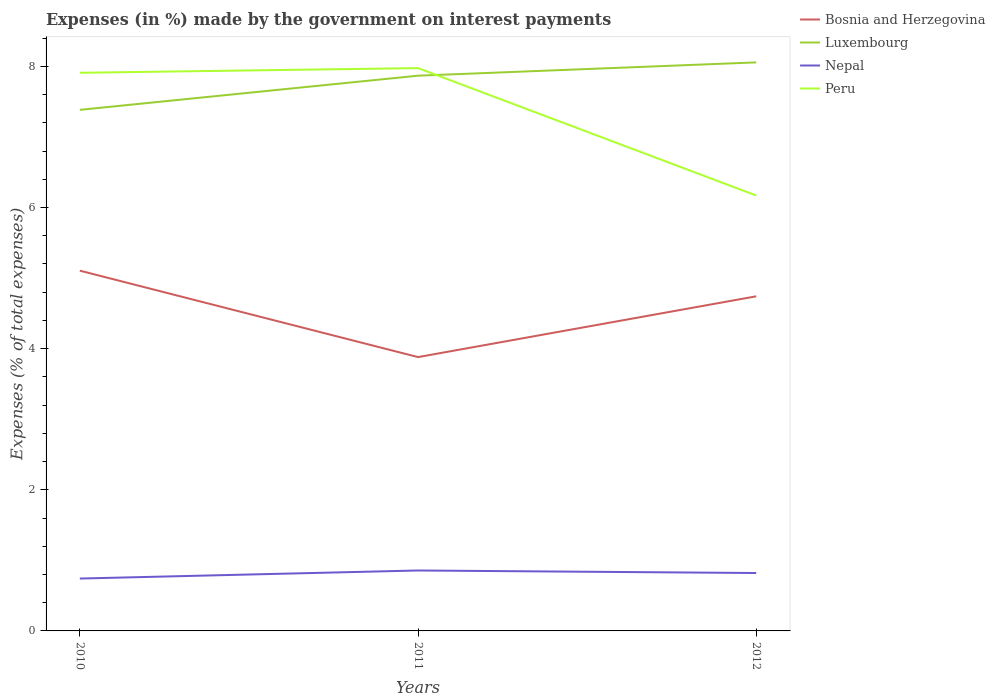How many different coloured lines are there?
Make the answer very short. 4. Across all years, what is the maximum percentage of expenses made by the government on interest payments in Luxembourg?
Your answer should be very brief. 7.38. In which year was the percentage of expenses made by the government on interest payments in Bosnia and Herzegovina maximum?
Provide a short and direct response. 2011. What is the total percentage of expenses made by the government on interest payments in Luxembourg in the graph?
Your answer should be compact. -0.67. What is the difference between the highest and the second highest percentage of expenses made by the government on interest payments in Nepal?
Give a very brief answer. 0.11. What is the difference between the highest and the lowest percentage of expenses made by the government on interest payments in Peru?
Provide a succinct answer. 2. Is the percentage of expenses made by the government on interest payments in Bosnia and Herzegovina strictly greater than the percentage of expenses made by the government on interest payments in Luxembourg over the years?
Make the answer very short. Yes. How many lines are there?
Provide a succinct answer. 4. Are the values on the major ticks of Y-axis written in scientific E-notation?
Offer a very short reply. No. Does the graph contain any zero values?
Make the answer very short. No. Does the graph contain grids?
Offer a terse response. No. How many legend labels are there?
Make the answer very short. 4. How are the legend labels stacked?
Your answer should be compact. Vertical. What is the title of the graph?
Your answer should be very brief. Expenses (in %) made by the government on interest payments. What is the label or title of the Y-axis?
Ensure brevity in your answer.  Expenses (% of total expenses). What is the Expenses (% of total expenses) of Bosnia and Herzegovina in 2010?
Your answer should be very brief. 5.11. What is the Expenses (% of total expenses) of Luxembourg in 2010?
Provide a succinct answer. 7.38. What is the Expenses (% of total expenses) of Nepal in 2010?
Give a very brief answer. 0.74. What is the Expenses (% of total expenses) of Peru in 2010?
Your answer should be very brief. 7.91. What is the Expenses (% of total expenses) in Bosnia and Herzegovina in 2011?
Your answer should be compact. 3.88. What is the Expenses (% of total expenses) in Luxembourg in 2011?
Ensure brevity in your answer.  7.87. What is the Expenses (% of total expenses) in Nepal in 2011?
Make the answer very short. 0.86. What is the Expenses (% of total expenses) of Peru in 2011?
Offer a terse response. 7.98. What is the Expenses (% of total expenses) in Bosnia and Herzegovina in 2012?
Offer a terse response. 4.74. What is the Expenses (% of total expenses) of Luxembourg in 2012?
Your answer should be very brief. 8.06. What is the Expenses (% of total expenses) in Nepal in 2012?
Give a very brief answer. 0.82. What is the Expenses (% of total expenses) in Peru in 2012?
Make the answer very short. 6.17. Across all years, what is the maximum Expenses (% of total expenses) in Bosnia and Herzegovina?
Give a very brief answer. 5.11. Across all years, what is the maximum Expenses (% of total expenses) of Luxembourg?
Offer a very short reply. 8.06. Across all years, what is the maximum Expenses (% of total expenses) in Nepal?
Provide a succinct answer. 0.86. Across all years, what is the maximum Expenses (% of total expenses) in Peru?
Provide a succinct answer. 7.98. Across all years, what is the minimum Expenses (% of total expenses) in Bosnia and Herzegovina?
Provide a succinct answer. 3.88. Across all years, what is the minimum Expenses (% of total expenses) in Luxembourg?
Your answer should be very brief. 7.38. Across all years, what is the minimum Expenses (% of total expenses) in Nepal?
Ensure brevity in your answer.  0.74. Across all years, what is the minimum Expenses (% of total expenses) of Peru?
Keep it short and to the point. 6.17. What is the total Expenses (% of total expenses) of Bosnia and Herzegovina in the graph?
Provide a short and direct response. 13.73. What is the total Expenses (% of total expenses) of Luxembourg in the graph?
Your response must be concise. 23.31. What is the total Expenses (% of total expenses) in Nepal in the graph?
Offer a very short reply. 2.42. What is the total Expenses (% of total expenses) of Peru in the graph?
Give a very brief answer. 22.05. What is the difference between the Expenses (% of total expenses) in Bosnia and Herzegovina in 2010 and that in 2011?
Your response must be concise. 1.22. What is the difference between the Expenses (% of total expenses) of Luxembourg in 2010 and that in 2011?
Make the answer very short. -0.48. What is the difference between the Expenses (% of total expenses) of Nepal in 2010 and that in 2011?
Provide a succinct answer. -0.11. What is the difference between the Expenses (% of total expenses) of Peru in 2010 and that in 2011?
Offer a terse response. -0.07. What is the difference between the Expenses (% of total expenses) in Bosnia and Herzegovina in 2010 and that in 2012?
Ensure brevity in your answer.  0.36. What is the difference between the Expenses (% of total expenses) of Luxembourg in 2010 and that in 2012?
Make the answer very short. -0.67. What is the difference between the Expenses (% of total expenses) of Nepal in 2010 and that in 2012?
Your response must be concise. -0.08. What is the difference between the Expenses (% of total expenses) of Peru in 2010 and that in 2012?
Provide a short and direct response. 1.74. What is the difference between the Expenses (% of total expenses) of Bosnia and Herzegovina in 2011 and that in 2012?
Give a very brief answer. -0.86. What is the difference between the Expenses (% of total expenses) in Luxembourg in 2011 and that in 2012?
Your answer should be compact. -0.19. What is the difference between the Expenses (% of total expenses) in Nepal in 2011 and that in 2012?
Offer a terse response. 0.04. What is the difference between the Expenses (% of total expenses) of Peru in 2011 and that in 2012?
Your answer should be compact. 1.81. What is the difference between the Expenses (% of total expenses) of Bosnia and Herzegovina in 2010 and the Expenses (% of total expenses) of Luxembourg in 2011?
Your response must be concise. -2.76. What is the difference between the Expenses (% of total expenses) of Bosnia and Herzegovina in 2010 and the Expenses (% of total expenses) of Nepal in 2011?
Provide a succinct answer. 4.25. What is the difference between the Expenses (% of total expenses) in Bosnia and Herzegovina in 2010 and the Expenses (% of total expenses) in Peru in 2011?
Your answer should be compact. -2.87. What is the difference between the Expenses (% of total expenses) in Luxembourg in 2010 and the Expenses (% of total expenses) in Nepal in 2011?
Make the answer very short. 6.53. What is the difference between the Expenses (% of total expenses) in Luxembourg in 2010 and the Expenses (% of total expenses) in Peru in 2011?
Ensure brevity in your answer.  -0.59. What is the difference between the Expenses (% of total expenses) of Nepal in 2010 and the Expenses (% of total expenses) of Peru in 2011?
Ensure brevity in your answer.  -7.23. What is the difference between the Expenses (% of total expenses) in Bosnia and Herzegovina in 2010 and the Expenses (% of total expenses) in Luxembourg in 2012?
Keep it short and to the point. -2.95. What is the difference between the Expenses (% of total expenses) of Bosnia and Herzegovina in 2010 and the Expenses (% of total expenses) of Nepal in 2012?
Keep it short and to the point. 4.28. What is the difference between the Expenses (% of total expenses) of Bosnia and Herzegovina in 2010 and the Expenses (% of total expenses) of Peru in 2012?
Offer a terse response. -1.06. What is the difference between the Expenses (% of total expenses) in Luxembourg in 2010 and the Expenses (% of total expenses) in Nepal in 2012?
Provide a succinct answer. 6.56. What is the difference between the Expenses (% of total expenses) of Luxembourg in 2010 and the Expenses (% of total expenses) of Peru in 2012?
Ensure brevity in your answer.  1.21. What is the difference between the Expenses (% of total expenses) in Nepal in 2010 and the Expenses (% of total expenses) in Peru in 2012?
Your answer should be compact. -5.43. What is the difference between the Expenses (% of total expenses) in Bosnia and Herzegovina in 2011 and the Expenses (% of total expenses) in Luxembourg in 2012?
Make the answer very short. -4.18. What is the difference between the Expenses (% of total expenses) of Bosnia and Herzegovina in 2011 and the Expenses (% of total expenses) of Nepal in 2012?
Make the answer very short. 3.06. What is the difference between the Expenses (% of total expenses) in Bosnia and Herzegovina in 2011 and the Expenses (% of total expenses) in Peru in 2012?
Ensure brevity in your answer.  -2.29. What is the difference between the Expenses (% of total expenses) of Luxembourg in 2011 and the Expenses (% of total expenses) of Nepal in 2012?
Your answer should be compact. 7.05. What is the difference between the Expenses (% of total expenses) of Luxembourg in 2011 and the Expenses (% of total expenses) of Peru in 2012?
Provide a succinct answer. 1.7. What is the difference between the Expenses (% of total expenses) of Nepal in 2011 and the Expenses (% of total expenses) of Peru in 2012?
Keep it short and to the point. -5.31. What is the average Expenses (% of total expenses) in Bosnia and Herzegovina per year?
Your answer should be compact. 4.58. What is the average Expenses (% of total expenses) in Luxembourg per year?
Make the answer very short. 7.77. What is the average Expenses (% of total expenses) in Nepal per year?
Ensure brevity in your answer.  0.81. What is the average Expenses (% of total expenses) in Peru per year?
Provide a succinct answer. 7.35. In the year 2010, what is the difference between the Expenses (% of total expenses) in Bosnia and Herzegovina and Expenses (% of total expenses) in Luxembourg?
Ensure brevity in your answer.  -2.28. In the year 2010, what is the difference between the Expenses (% of total expenses) of Bosnia and Herzegovina and Expenses (% of total expenses) of Nepal?
Your answer should be compact. 4.36. In the year 2010, what is the difference between the Expenses (% of total expenses) of Bosnia and Herzegovina and Expenses (% of total expenses) of Peru?
Provide a short and direct response. -2.8. In the year 2010, what is the difference between the Expenses (% of total expenses) in Luxembourg and Expenses (% of total expenses) in Nepal?
Offer a very short reply. 6.64. In the year 2010, what is the difference between the Expenses (% of total expenses) in Luxembourg and Expenses (% of total expenses) in Peru?
Offer a terse response. -0.53. In the year 2010, what is the difference between the Expenses (% of total expenses) of Nepal and Expenses (% of total expenses) of Peru?
Give a very brief answer. -7.17. In the year 2011, what is the difference between the Expenses (% of total expenses) in Bosnia and Herzegovina and Expenses (% of total expenses) in Luxembourg?
Ensure brevity in your answer.  -3.99. In the year 2011, what is the difference between the Expenses (% of total expenses) in Bosnia and Herzegovina and Expenses (% of total expenses) in Nepal?
Your response must be concise. 3.02. In the year 2011, what is the difference between the Expenses (% of total expenses) in Bosnia and Herzegovina and Expenses (% of total expenses) in Peru?
Provide a succinct answer. -4.1. In the year 2011, what is the difference between the Expenses (% of total expenses) in Luxembourg and Expenses (% of total expenses) in Nepal?
Offer a terse response. 7.01. In the year 2011, what is the difference between the Expenses (% of total expenses) in Luxembourg and Expenses (% of total expenses) in Peru?
Provide a short and direct response. -0.11. In the year 2011, what is the difference between the Expenses (% of total expenses) in Nepal and Expenses (% of total expenses) in Peru?
Your answer should be compact. -7.12. In the year 2012, what is the difference between the Expenses (% of total expenses) in Bosnia and Herzegovina and Expenses (% of total expenses) in Luxembourg?
Keep it short and to the point. -3.31. In the year 2012, what is the difference between the Expenses (% of total expenses) in Bosnia and Herzegovina and Expenses (% of total expenses) in Nepal?
Your answer should be compact. 3.92. In the year 2012, what is the difference between the Expenses (% of total expenses) of Bosnia and Herzegovina and Expenses (% of total expenses) of Peru?
Provide a short and direct response. -1.43. In the year 2012, what is the difference between the Expenses (% of total expenses) in Luxembourg and Expenses (% of total expenses) in Nepal?
Give a very brief answer. 7.24. In the year 2012, what is the difference between the Expenses (% of total expenses) in Luxembourg and Expenses (% of total expenses) in Peru?
Your answer should be very brief. 1.89. In the year 2012, what is the difference between the Expenses (% of total expenses) in Nepal and Expenses (% of total expenses) in Peru?
Your answer should be very brief. -5.35. What is the ratio of the Expenses (% of total expenses) in Bosnia and Herzegovina in 2010 to that in 2011?
Give a very brief answer. 1.32. What is the ratio of the Expenses (% of total expenses) of Luxembourg in 2010 to that in 2011?
Your response must be concise. 0.94. What is the ratio of the Expenses (% of total expenses) of Nepal in 2010 to that in 2011?
Give a very brief answer. 0.87. What is the ratio of the Expenses (% of total expenses) of Peru in 2010 to that in 2011?
Give a very brief answer. 0.99. What is the ratio of the Expenses (% of total expenses) in Bosnia and Herzegovina in 2010 to that in 2012?
Offer a terse response. 1.08. What is the ratio of the Expenses (% of total expenses) of Luxembourg in 2010 to that in 2012?
Offer a very short reply. 0.92. What is the ratio of the Expenses (% of total expenses) of Nepal in 2010 to that in 2012?
Give a very brief answer. 0.9. What is the ratio of the Expenses (% of total expenses) in Peru in 2010 to that in 2012?
Offer a terse response. 1.28. What is the ratio of the Expenses (% of total expenses) in Bosnia and Herzegovina in 2011 to that in 2012?
Your response must be concise. 0.82. What is the ratio of the Expenses (% of total expenses) in Luxembourg in 2011 to that in 2012?
Provide a short and direct response. 0.98. What is the ratio of the Expenses (% of total expenses) in Nepal in 2011 to that in 2012?
Offer a terse response. 1.04. What is the ratio of the Expenses (% of total expenses) in Peru in 2011 to that in 2012?
Provide a short and direct response. 1.29. What is the difference between the highest and the second highest Expenses (% of total expenses) of Bosnia and Herzegovina?
Your answer should be compact. 0.36. What is the difference between the highest and the second highest Expenses (% of total expenses) of Luxembourg?
Your answer should be very brief. 0.19. What is the difference between the highest and the second highest Expenses (% of total expenses) of Nepal?
Your answer should be very brief. 0.04. What is the difference between the highest and the second highest Expenses (% of total expenses) in Peru?
Offer a terse response. 0.07. What is the difference between the highest and the lowest Expenses (% of total expenses) in Bosnia and Herzegovina?
Ensure brevity in your answer.  1.22. What is the difference between the highest and the lowest Expenses (% of total expenses) of Luxembourg?
Keep it short and to the point. 0.67. What is the difference between the highest and the lowest Expenses (% of total expenses) in Nepal?
Offer a very short reply. 0.11. What is the difference between the highest and the lowest Expenses (% of total expenses) of Peru?
Give a very brief answer. 1.81. 